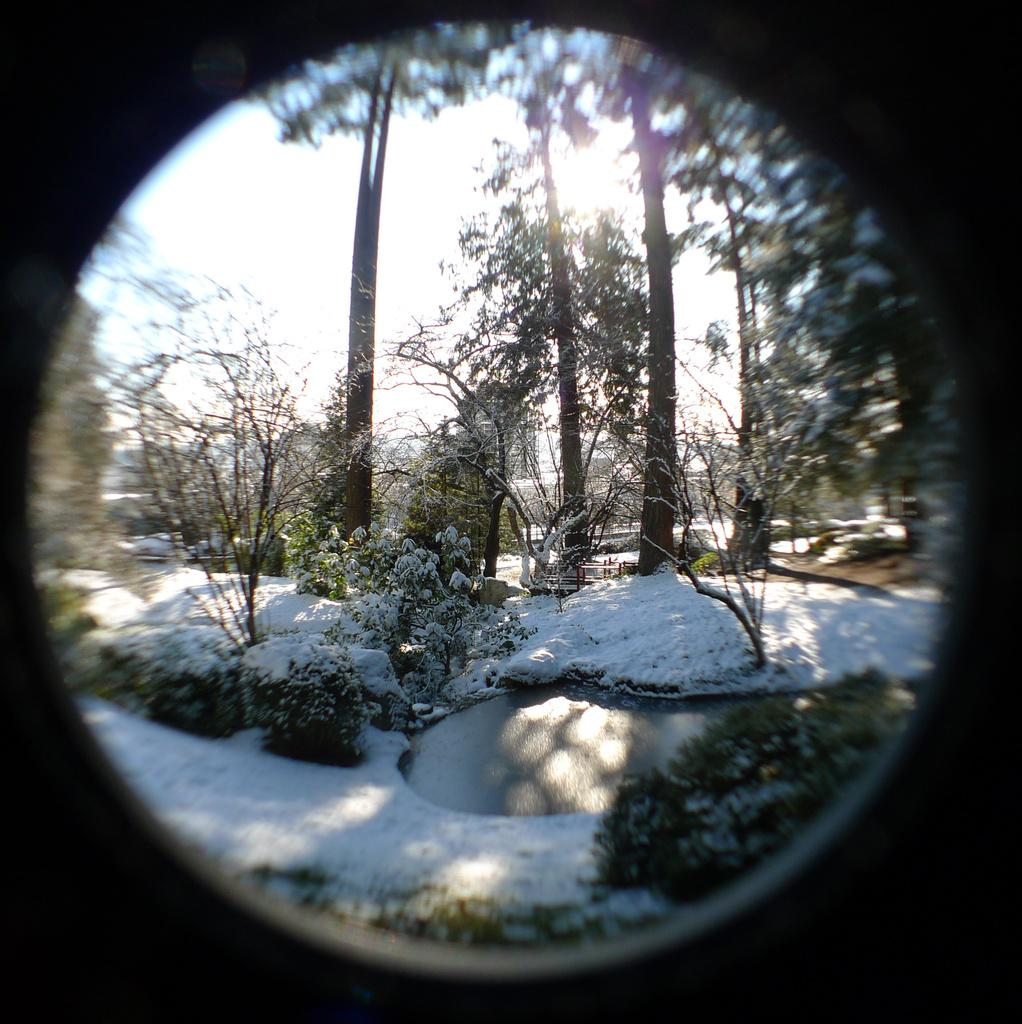What type of surface is being reflected in the image? The image appears to be a reflection in a mirror. What natural elements can be seen in the reflection? There is a reflection of snow, plants, trees, and water in the mirror. What is visible in the sky behind the trees in the reflection? The sky is visible behind the trees in the reflection. How many rings are visible on the trees in the reflection? There are no rings visible on the trees in the reflection; we can only see the reflection of the trees themselves. Is there a jail visible in the reflection? There is no jail present in the image or the reflection. 